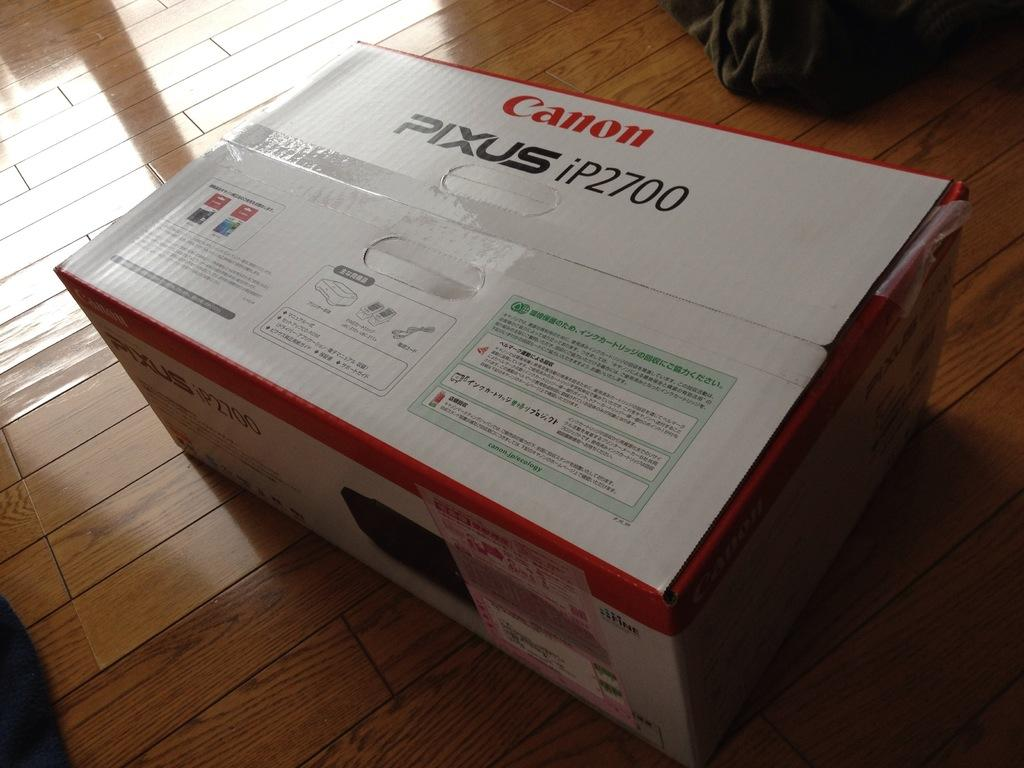<image>
Offer a succinct explanation of the picture presented. A box for the Canon Pixus iP2700 is sitting on the floor. 